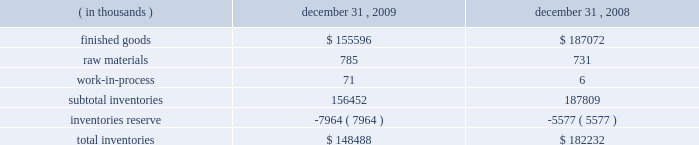To the two-class method .
The provisions of this guidance were required for fiscal years beginning after december 15 , 2008 .
The company has adopted this guidance for current period computations of earnings per share , and has updated prior period computations of earnings per share .
The adoption of this guidance in the first quarter of 2009 did not have a material impact on the company 2019s computation of earnings per share .
Refer to note 11 for further discussion .
In june 2008 , the fasb issued accounting guidance addressing the determination of whether provisions that introduce adjustment features ( including contingent adjustment features ) would prevent treating a derivative contract or an embedded derivative on a company 2019s own stock as indexed solely to the company 2019s stock .
This guidance was effective for fiscal years beginning after december 15 , 2008 .
The adoption of this guidance in the first quarter of 2009 did not have any impact on the company 2019s consolidated financial statements .
In march 2008 , the fasb issued accounting guidance intended to improve financial reporting about derivative instruments and hedging activities by requiring enhanced disclosures to enable investors to better understand their effects on an entity 2019s financial position , financial performance , and cash flows .
This guidance was effective for the fiscal years and interim periods beginning after november 15 , 2008 .
The adoption of this guidance in the first quarter of 2009 did not have any impact on the company 2019s consolidated financial statements .
In december 2007 , the fasb issued replacement guidance that requires the acquirer of a business to recognize and measure the identifiable assets acquired , the liabilities assumed , and any non-controlling interest in the acquired entity at fair value .
This replacement guidance also requires transaction costs related to the business combination to be expensed as incurred .
It was effective for business combinations for which the acquisition date was on or after the start of the fiscal year beginning after december 15 , 2008 .
The adoption of this guidance in the first quarter of 2009 did not have any impact on the company 2019s consolidated financial statements .
In december 2007 , the fasb issued accounting guidance that establishes accounting and reporting standards for the noncontrolling interest in a subsidiary and for the deconsolidation of a subsidiary .
This guidance was effective for fiscal years beginning after december 15 , 2008 .
The adoption of this guidance in the first quarter of 2009 did not have any impact on the company 2019s consolidated financial statements .
In september 2006 , the fasb issued accounting guidance which defines fair value , establishes a framework for measuring fair value in accordance with generally accepted accounting principles and expands disclosures about fair value measurements .
This guidance was effective for fiscal years beginning after november 15 , 2007 , however the fasb delayed the effective date to fiscal years beginning after november 15 , 2008 for nonfinancial assets and nonfinancial liabilities , except those items recognized or disclosed at fair value on an annual or more frequent basis .
The adoption of this guidance for nonfinancial assets and liabilities in the first quarter of 2009 did not have any impact on the company 2019s consolidated financial statements .
Inventories inventories consisted of the following: .

What was the percent of the change in the finished goods from 2008 to 2009? 
Rationale: the finished goods decreased by 16.8% from 2008 to 2009
Computations: ((155596 - 187072) / 187072)
Answer: -0.16826. 